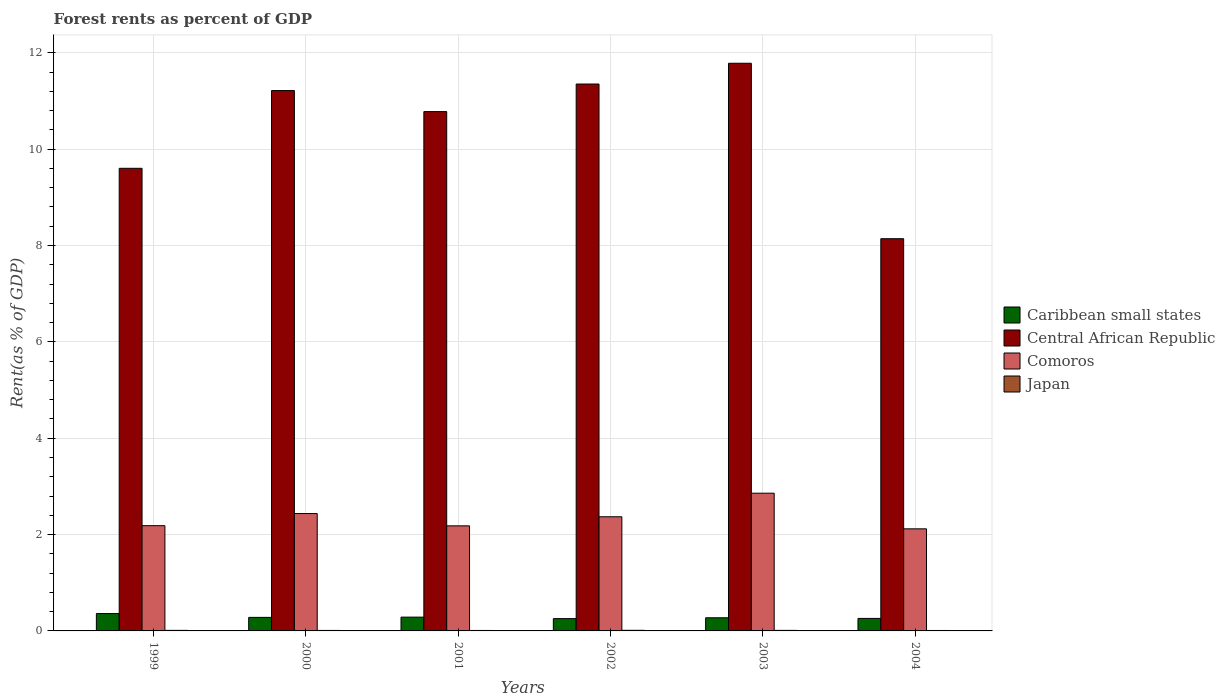How many groups of bars are there?
Your response must be concise. 6. Are the number of bars on each tick of the X-axis equal?
Give a very brief answer. Yes. What is the forest rent in Caribbean small states in 2001?
Your response must be concise. 0.29. Across all years, what is the maximum forest rent in Central African Republic?
Make the answer very short. 11.78. Across all years, what is the minimum forest rent in Comoros?
Your answer should be compact. 2.12. What is the total forest rent in Japan in the graph?
Provide a succinct answer. 0.06. What is the difference between the forest rent in Caribbean small states in 1999 and that in 2001?
Provide a short and direct response. 0.07. What is the difference between the forest rent in Caribbean small states in 2000 and the forest rent in Central African Republic in 1999?
Your response must be concise. -9.32. What is the average forest rent in Comoros per year?
Offer a very short reply. 2.36. In the year 2001, what is the difference between the forest rent in Comoros and forest rent in Japan?
Make the answer very short. 2.17. What is the ratio of the forest rent in Comoros in 1999 to that in 2000?
Keep it short and to the point. 0.9. Is the difference between the forest rent in Comoros in 2001 and 2003 greater than the difference between the forest rent in Japan in 2001 and 2003?
Give a very brief answer. No. What is the difference between the highest and the second highest forest rent in Japan?
Keep it short and to the point. 0. What is the difference between the highest and the lowest forest rent in Comoros?
Make the answer very short. 0.74. In how many years, is the forest rent in Japan greater than the average forest rent in Japan taken over all years?
Provide a succinct answer. 3. Is it the case that in every year, the sum of the forest rent in Central African Republic and forest rent in Japan is greater than the sum of forest rent in Comoros and forest rent in Caribbean small states?
Your answer should be very brief. Yes. What does the 1st bar from the left in 2000 represents?
Give a very brief answer. Caribbean small states. What does the 3rd bar from the right in 2000 represents?
Keep it short and to the point. Central African Republic. How many bars are there?
Your response must be concise. 24. Are all the bars in the graph horizontal?
Ensure brevity in your answer.  No. How many years are there in the graph?
Give a very brief answer. 6. What is the difference between two consecutive major ticks on the Y-axis?
Your answer should be compact. 2. Are the values on the major ticks of Y-axis written in scientific E-notation?
Make the answer very short. No. Does the graph contain any zero values?
Keep it short and to the point. No. How many legend labels are there?
Provide a short and direct response. 4. How are the legend labels stacked?
Your answer should be compact. Vertical. What is the title of the graph?
Offer a very short reply. Forest rents as percent of GDP. What is the label or title of the Y-axis?
Provide a succinct answer. Rent(as % of GDP). What is the Rent(as % of GDP) in Caribbean small states in 1999?
Give a very brief answer. 0.36. What is the Rent(as % of GDP) in Central African Republic in 1999?
Your answer should be very brief. 9.6. What is the Rent(as % of GDP) of Comoros in 1999?
Make the answer very short. 2.18. What is the Rent(as % of GDP) of Japan in 1999?
Your answer should be very brief. 0.01. What is the Rent(as % of GDP) in Caribbean small states in 2000?
Make the answer very short. 0.28. What is the Rent(as % of GDP) of Central African Republic in 2000?
Provide a short and direct response. 11.22. What is the Rent(as % of GDP) of Comoros in 2000?
Offer a very short reply. 2.44. What is the Rent(as % of GDP) in Japan in 2000?
Make the answer very short. 0.01. What is the Rent(as % of GDP) in Caribbean small states in 2001?
Give a very brief answer. 0.29. What is the Rent(as % of GDP) of Central African Republic in 2001?
Your response must be concise. 10.78. What is the Rent(as % of GDP) in Comoros in 2001?
Make the answer very short. 2.18. What is the Rent(as % of GDP) of Japan in 2001?
Keep it short and to the point. 0.01. What is the Rent(as % of GDP) in Caribbean small states in 2002?
Your answer should be compact. 0.26. What is the Rent(as % of GDP) of Central African Republic in 2002?
Provide a succinct answer. 11.35. What is the Rent(as % of GDP) in Comoros in 2002?
Keep it short and to the point. 2.37. What is the Rent(as % of GDP) in Japan in 2002?
Your response must be concise. 0.01. What is the Rent(as % of GDP) of Caribbean small states in 2003?
Your answer should be very brief. 0.27. What is the Rent(as % of GDP) of Central African Republic in 2003?
Make the answer very short. 11.78. What is the Rent(as % of GDP) in Comoros in 2003?
Your answer should be very brief. 2.86. What is the Rent(as % of GDP) in Japan in 2003?
Your response must be concise. 0.01. What is the Rent(as % of GDP) of Caribbean small states in 2004?
Make the answer very short. 0.26. What is the Rent(as % of GDP) in Central African Republic in 2004?
Your answer should be very brief. 8.14. What is the Rent(as % of GDP) of Comoros in 2004?
Your answer should be compact. 2.12. What is the Rent(as % of GDP) in Japan in 2004?
Your answer should be compact. 0.01. Across all years, what is the maximum Rent(as % of GDP) in Caribbean small states?
Provide a succinct answer. 0.36. Across all years, what is the maximum Rent(as % of GDP) in Central African Republic?
Provide a succinct answer. 11.78. Across all years, what is the maximum Rent(as % of GDP) in Comoros?
Your response must be concise. 2.86. Across all years, what is the maximum Rent(as % of GDP) of Japan?
Offer a terse response. 0.01. Across all years, what is the minimum Rent(as % of GDP) of Caribbean small states?
Keep it short and to the point. 0.26. Across all years, what is the minimum Rent(as % of GDP) of Central African Republic?
Provide a short and direct response. 8.14. Across all years, what is the minimum Rent(as % of GDP) of Comoros?
Offer a terse response. 2.12. Across all years, what is the minimum Rent(as % of GDP) in Japan?
Provide a succinct answer. 0.01. What is the total Rent(as % of GDP) in Caribbean small states in the graph?
Keep it short and to the point. 1.72. What is the total Rent(as % of GDP) of Central African Republic in the graph?
Your answer should be compact. 62.88. What is the total Rent(as % of GDP) of Comoros in the graph?
Ensure brevity in your answer.  14.15. What is the total Rent(as % of GDP) of Japan in the graph?
Provide a succinct answer. 0.06. What is the difference between the Rent(as % of GDP) of Caribbean small states in 1999 and that in 2000?
Your answer should be very brief. 0.08. What is the difference between the Rent(as % of GDP) in Central African Republic in 1999 and that in 2000?
Your response must be concise. -1.61. What is the difference between the Rent(as % of GDP) of Comoros in 1999 and that in 2000?
Ensure brevity in your answer.  -0.25. What is the difference between the Rent(as % of GDP) in Japan in 1999 and that in 2000?
Your response must be concise. 0. What is the difference between the Rent(as % of GDP) of Caribbean small states in 1999 and that in 2001?
Make the answer very short. 0.07. What is the difference between the Rent(as % of GDP) in Central African Republic in 1999 and that in 2001?
Offer a very short reply. -1.18. What is the difference between the Rent(as % of GDP) of Comoros in 1999 and that in 2001?
Offer a terse response. 0. What is the difference between the Rent(as % of GDP) of Japan in 1999 and that in 2001?
Provide a short and direct response. 0. What is the difference between the Rent(as % of GDP) in Caribbean small states in 1999 and that in 2002?
Offer a very short reply. 0.11. What is the difference between the Rent(as % of GDP) of Central African Republic in 1999 and that in 2002?
Keep it short and to the point. -1.75. What is the difference between the Rent(as % of GDP) in Comoros in 1999 and that in 2002?
Offer a terse response. -0.18. What is the difference between the Rent(as % of GDP) of Japan in 1999 and that in 2002?
Your response must be concise. -0. What is the difference between the Rent(as % of GDP) of Caribbean small states in 1999 and that in 2003?
Provide a short and direct response. 0.09. What is the difference between the Rent(as % of GDP) of Central African Republic in 1999 and that in 2003?
Provide a short and direct response. -2.18. What is the difference between the Rent(as % of GDP) of Comoros in 1999 and that in 2003?
Provide a succinct answer. -0.67. What is the difference between the Rent(as % of GDP) of Japan in 1999 and that in 2003?
Ensure brevity in your answer.  0. What is the difference between the Rent(as % of GDP) of Caribbean small states in 1999 and that in 2004?
Offer a very short reply. 0.1. What is the difference between the Rent(as % of GDP) of Central African Republic in 1999 and that in 2004?
Offer a terse response. 1.46. What is the difference between the Rent(as % of GDP) of Comoros in 1999 and that in 2004?
Your response must be concise. 0.07. What is the difference between the Rent(as % of GDP) of Japan in 1999 and that in 2004?
Ensure brevity in your answer.  0. What is the difference between the Rent(as % of GDP) of Caribbean small states in 2000 and that in 2001?
Provide a short and direct response. -0. What is the difference between the Rent(as % of GDP) of Central African Republic in 2000 and that in 2001?
Offer a very short reply. 0.44. What is the difference between the Rent(as % of GDP) of Comoros in 2000 and that in 2001?
Your answer should be very brief. 0.26. What is the difference between the Rent(as % of GDP) in Japan in 2000 and that in 2001?
Provide a short and direct response. 0. What is the difference between the Rent(as % of GDP) of Caribbean small states in 2000 and that in 2002?
Offer a terse response. 0.03. What is the difference between the Rent(as % of GDP) in Central African Republic in 2000 and that in 2002?
Offer a very short reply. -0.14. What is the difference between the Rent(as % of GDP) of Comoros in 2000 and that in 2002?
Offer a terse response. 0.07. What is the difference between the Rent(as % of GDP) of Japan in 2000 and that in 2002?
Give a very brief answer. -0. What is the difference between the Rent(as % of GDP) in Caribbean small states in 2000 and that in 2003?
Give a very brief answer. 0.01. What is the difference between the Rent(as % of GDP) of Central African Republic in 2000 and that in 2003?
Provide a succinct answer. -0.57. What is the difference between the Rent(as % of GDP) in Comoros in 2000 and that in 2003?
Your answer should be very brief. -0.42. What is the difference between the Rent(as % of GDP) of Japan in 2000 and that in 2003?
Offer a very short reply. -0. What is the difference between the Rent(as % of GDP) in Caribbean small states in 2000 and that in 2004?
Offer a terse response. 0.02. What is the difference between the Rent(as % of GDP) in Central African Republic in 2000 and that in 2004?
Your answer should be very brief. 3.08. What is the difference between the Rent(as % of GDP) in Comoros in 2000 and that in 2004?
Make the answer very short. 0.32. What is the difference between the Rent(as % of GDP) in Caribbean small states in 2001 and that in 2002?
Offer a very short reply. 0.03. What is the difference between the Rent(as % of GDP) in Central African Republic in 2001 and that in 2002?
Your response must be concise. -0.57. What is the difference between the Rent(as % of GDP) of Comoros in 2001 and that in 2002?
Your response must be concise. -0.19. What is the difference between the Rent(as % of GDP) in Japan in 2001 and that in 2002?
Offer a very short reply. -0. What is the difference between the Rent(as % of GDP) of Caribbean small states in 2001 and that in 2003?
Ensure brevity in your answer.  0.01. What is the difference between the Rent(as % of GDP) of Central African Republic in 2001 and that in 2003?
Offer a terse response. -1. What is the difference between the Rent(as % of GDP) in Comoros in 2001 and that in 2003?
Offer a terse response. -0.68. What is the difference between the Rent(as % of GDP) of Japan in 2001 and that in 2003?
Keep it short and to the point. -0. What is the difference between the Rent(as % of GDP) of Caribbean small states in 2001 and that in 2004?
Ensure brevity in your answer.  0.03. What is the difference between the Rent(as % of GDP) in Central African Republic in 2001 and that in 2004?
Provide a short and direct response. 2.64. What is the difference between the Rent(as % of GDP) in Comoros in 2001 and that in 2004?
Ensure brevity in your answer.  0.06. What is the difference between the Rent(as % of GDP) in Japan in 2001 and that in 2004?
Offer a terse response. 0. What is the difference between the Rent(as % of GDP) of Caribbean small states in 2002 and that in 2003?
Your answer should be compact. -0.02. What is the difference between the Rent(as % of GDP) of Central African Republic in 2002 and that in 2003?
Provide a short and direct response. -0.43. What is the difference between the Rent(as % of GDP) of Comoros in 2002 and that in 2003?
Your response must be concise. -0.49. What is the difference between the Rent(as % of GDP) of Japan in 2002 and that in 2003?
Make the answer very short. 0. What is the difference between the Rent(as % of GDP) of Caribbean small states in 2002 and that in 2004?
Keep it short and to the point. -0. What is the difference between the Rent(as % of GDP) of Central African Republic in 2002 and that in 2004?
Your response must be concise. 3.21. What is the difference between the Rent(as % of GDP) in Comoros in 2002 and that in 2004?
Offer a terse response. 0.25. What is the difference between the Rent(as % of GDP) in Japan in 2002 and that in 2004?
Your response must be concise. 0. What is the difference between the Rent(as % of GDP) in Caribbean small states in 2003 and that in 2004?
Provide a succinct answer. 0.01. What is the difference between the Rent(as % of GDP) of Central African Republic in 2003 and that in 2004?
Offer a very short reply. 3.64. What is the difference between the Rent(as % of GDP) of Comoros in 2003 and that in 2004?
Keep it short and to the point. 0.74. What is the difference between the Rent(as % of GDP) in Japan in 2003 and that in 2004?
Give a very brief answer. 0. What is the difference between the Rent(as % of GDP) in Caribbean small states in 1999 and the Rent(as % of GDP) in Central African Republic in 2000?
Your answer should be very brief. -10.86. What is the difference between the Rent(as % of GDP) in Caribbean small states in 1999 and the Rent(as % of GDP) in Comoros in 2000?
Offer a very short reply. -2.08. What is the difference between the Rent(as % of GDP) of Caribbean small states in 1999 and the Rent(as % of GDP) of Japan in 2000?
Offer a terse response. 0.35. What is the difference between the Rent(as % of GDP) in Central African Republic in 1999 and the Rent(as % of GDP) in Comoros in 2000?
Offer a very short reply. 7.17. What is the difference between the Rent(as % of GDP) of Central African Republic in 1999 and the Rent(as % of GDP) of Japan in 2000?
Offer a very short reply. 9.59. What is the difference between the Rent(as % of GDP) in Comoros in 1999 and the Rent(as % of GDP) in Japan in 2000?
Offer a very short reply. 2.17. What is the difference between the Rent(as % of GDP) of Caribbean small states in 1999 and the Rent(as % of GDP) of Central African Republic in 2001?
Offer a terse response. -10.42. What is the difference between the Rent(as % of GDP) in Caribbean small states in 1999 and the Rent(as % of GDP) in Comoros in 2001?
Offer a terse response. -1.82. What is the difference between the Rent(as % of GDP) of Caribbean small states in 1999 and the Rent(as % of GDP) of Japan in 2001?
Ensure brevity in your answer.  0.35. What is the difference between the Rent(as % of GDP) in Central African Republic in 1999 and the Rent(as % of GDP) in Comoros in 2001?
Offer a terse response. 7.42. What is the difference between the Rent(as % of GDP) in Central African Republic in 1999 and the Rent(as % of GDP) in Japan in 2001?
Your answer should be compact. 9.59. What is the difference between the Rent(as % of GDP) of Comoros in 1999 and the Rent(as % of GDP) of Japan in 2001?
Keep it short and to the point. 2.17. What is the difference between the Rent(as % of GDP) of Caribbean small states in 1999 and the Rent(as % of GDP) of Central African Republic in 2002?
Give a very brief answer. -10.99. What is the difference between the Rent(as % of GDP) in Caribbean small states in 1999 and the Rent(as % of GDP) in Comoros in 2002?
Offer a very short reply. -2.01. What is the difference between the Rent(as % of GDP) in Caribbean small states in 1999 and the Rent(as % of GDP) in Japan in 2002?
Keep it short and to the point. 0.35. What is the difference between the Rent(as % of GDP) of Central African Republic in 1999 and the Rent(as % of GDP) of Comoros in 2002?
Provide a short and direct response. 7.23. What is the difference between the Rent(as % of GDP) in Central African Republic in 1999 and the Rent(as % of GDP) in Japan in 2002?
Your response must be concise. 9.59. What is the difference between the Rent(as % of GDP) in Comoros in 1999 and the Rent(as % of GDP) in Japan in 2002?
Make the answer very short. 2.17. What is the difference between the Rent(as % of GDP) of Caribbean small states in 1999 and the Rent(as % of GDP) of Central African Republic in 2003?
Provide a short and direct response. -11.42. What is the difference between the Rent(as % of GDP) of Caribbean small states in 1999 and the Rent(as % of GDP) of Comoros in 2003?
Offer a terse response. -2.5. What is the difference between the Rent(as % of GDP) of Caribbean small states in 1999 and the Rent(as % of GDP) of Japan in 2003?
Offer a terse response. 0.35. What is the difference between the Rent(as % of GDP) of Central African Republic in 1999 and the Rent(as % of GDP) of Comoros in 2003?
Make the answer very short. 6.74. What is the difference between the Rent(as % of GDP) in Central African Republic in 1999 and the Rent(as % of GDP) in Japan in 2003?
Give a very brief answer. 9.59. What is the difference between the Rent(as % of GDP) in Comoros in 1999 and the Rent(as % of GDP) in Japan in 2003?
Provide a short and direct response. 2.17. What is the difference between the Rent(as % of GDP) of Caribbean small states in 1999 and the Rent(as % of GDP) of Central African Republic in 2004?
Ensure brevity in your answer.  -7.78. What is the difference between the Rent(as % of GDP) of Caribbean small states in 1999 and the Rent(as % of GDP) of Comoros in 2004?
Offer a terse response. -1.76. What is the difference between the Rent(as % of GDP) in Caribbean small states in 1999 and the Rent(as % of GDP) in Japan in 2004?
Your answer should be compact. 0.35. What is the difference between the Rent(as % of GDP) in Central African Republic in 1999 and the Rent(as % of GDP) in Comoros in 2004?
Your response must be concise. 7.48. What is the difference between the Rent(as % of GDP) in Central African Republic in 1999 and the Rent(as % of GDP) in Japan in 2004?
Provide a short and direct response. 9.59. What is the difference between the Rent(as % of GDP) in Comoros in 1999 and the Rent(as % of GDP) in Japan in 2004?
Provide a succinct answer. 2.18. What is the difference between the Rent(as % of GDP) of Caribbean small states in 2000 and the Rent(as % of GDP) of Central African Republic in 2001?
Provide a short and direct response. -10.5. What is the difference between the Rent(as % of GDP) in Caribbean small states in 2000 and the Rent(as % of GDP) in Comoros in 2001?
Ensure brevity in your answer.  -1.9. What is the difference between the Rent(as % of GDP) of Caribbean small states in 2000 and the Rent(as % of GDP) of Japan in 2001?
Your answer should be compact. 0.27. What is the difference between the Rent(as % of GDP) of Central African Republic in 2000 and the Rent(as % of GDP) of Comoros in 2001?
Offer a very short reply. 9.04. What is the difference between the Rent(as % of GDP) in Central African Republic in 2000 and the Rent(as % of GDP) in Japan in 2001?
Provide a short and direct response. 11.21. What is the difference between the Rent(as % of GDP) of Comoros in 2000 and the Rent(as % of GDP) of Japan in 2001?
Keep it short and to the point. 2.43. What is the difference between the Rent(as % of GDP) of Caribbean small states in 2000 and the Rent(as % of GDP) of Central African Republic in 2002?
Your answer should be very brief. -11.07. What is the difference between the Rent(as % of GDP) in Caribbean small states in 2000 and the Rent(as % of GDP) in Comoros in 2002?
Keep it short and to the point. -2.09. What is the difference between the Rent(as % of GDP) in Caribbean small states in 2000 and the Rent(as % of GDP) in Japan in 2002?
Provide a short and direct response. 0.27. What is the difference between the Rent(as % of GDP) in Central African Republic in 2000 and the Rent(as % of GDP) in Comoros in 2002?
Your answer should be very brief. 8.85. What is the difference between the Rent(as % of GDP) in Central African Republic in 2000 and the Rent(as % of GDP) in Japan in 2002?
Ensure brevity in your answer.  11.2. What is the difference between the Rent(as % of GDP) in Comoros in 2000 and the Rent(as % of GDP) in Japan in 2002?
Keep it short and to the point. 2.42. What is the difference between the Rent(as % of GDP) of Caribbean small states in 2000 and the Rent(as % of GDP) of Central African Republic in 2003?
Your answer should be very brief. -11.5. What is the difference between the Rent(as % of GDP) of Caribbean small states in 2000 and the Rent(as % of GDP) of Comoros in 2003?
Provide a succinct answer. -2.58. What is the difference between the Rent(as % of GDP) in Caribbean small states in 2000 and the Rent(as % of GDP) in Japan in 2003?
Offer a terse response. 0.27. What is the difference between the Rent(as % of GDP) in Central African Republic in 2000 and the Rent(as % of GDP) in Comoros in 2003?
Make the answer very short. 8.36. What is the difference between the Rent(as % of GDP) of Central African Republic in 2000 and the Rent(as % of GDP) of Japan in 2003?
Give a very brief answer. 11.21. What is the difference between the Rent(as % of GDP) of Comoros in 2000 and the Rent(as % of GDP) of Japan in 2003?
Ensure brevity in your answer.  2.43. What is the difference between the Rent(as % of GDP) of Caribbean small states in 2000 and the Rent(as % of GDP) of Central African Republic in 2004?
Your answer should be very brief. -7.86. What is the difference between the Rent(as % of GDP) of Caribbean small states in 2000 and the Rent(as % of GDP) of Comoros in 2004?
Make the answer very short. -1.84. What is the difference between the Rent(as % of GDP) of Caribbean small states in 2000 and the Rent(as % of GDP) of Japan in 2004?
Give a very brief answer. 0.27. What is the difference between the Rent(as % of GDP) in Central African Republic in 2000 and the Rent(as % of GDP) in Comoros in 2004?
Give a very brief answer. 9.1. What is the difference between the Rent(as % of GDP) of Central African Republic in 2000 and the Rent(as % of GDP) of Japan in 2004?
Offer a terse response. 11.21. What is the difference between the Rent(as % of GDP) in Comoros in 2000 and the Rent(as % of GDP) in Japan in 2004?
Your response must be concise. 2.43. What is the difference between the Rent(as % of GDP) of Caribbean small states in 2001 and the Rent(as % of GDP) of Central African Republic in 2002?
Provide a short and direct response. -11.07. What is the difference between the Rent(as % of GDP) in Caribbean small states in 2001 and the Rent(as % of GDP) in Comoros in 2002?
Keep it short and to the point. -2.08. What is the difference between the Rent(as % of GDP) in Caribbean small states in 2001 and the Rent(as % of GDP) in Japan in 2002?
Keep it short and to the point. 0.27. What is the difference between the Rent(as % of GDP) of Central African Republic in 2001 and the Rent(as % of GDP) of Comoros in 2002?
Provide a succinct answer. 8.41. What is the difference between the Rent(as % of GDP) of Central African Republic in 2001 and the Rent(as % of GDP) of Japan in 2002?
Provide a succinct answer. 10.77. What is the difference between the Rent(as % of GDP) in Comoros in 2001 and the Rent(as % of GDP) in Japan in 2002?
Offer a terse response. 2.17. What is the difference between the Rent(as % of GDP) of Caribbean small states in 2001 and the Rent(as % of GDP) of Central African Republic in 2003?
Your answer should be very brief. -11.5. What is the difference between the Rent(as % of GDP) in Caribbean small states in 2001 and the Rent(as % of GDP) in Comoros in 2003?
Provide a succinct answer. -2.57. What is the difference between the Rent(as % of GDP) in Caribbean small states in 2001 and the Rent(as % of GDP) in Japan in 2003?
Give a very brief answer. 0.28. What is the difference between the Rent(as % of GDP) in Central African Republic in 2001 and the Rent(as % of GDP) in Comoros in 2003?
Keep it short and to the point. 7.92. What is the difference between the Rent(as % of GDP) of Central African Republic in 2001 and the Rent(as % of GDP) of Japan in 2003?
Your response must be concise. 10.77. What is the difference between the Rent(as % of GDP) of Comoros in 2001 and the Rent(as % of GDP) of Japan in 2003?
Give a very brief answer. 2.17. What is the difference between the Rent(as % of GDP) in Caribbean small states in 2001 and the Rent(as % of GDP) in Central African Republic in 2004?
Ensure brevity in your answer.  -7.86. What is the difference between the Rent(as % of GDP) of Caribbean small states in 2001 and the Rent(as % of GDP) of Comoros in 2004?
Keep it short and to the point. -1.83. What is the difference between the Rent(as % of GDP) in Caribbean small states in 2001 and the Rent(as % of GDP) in Japan in 2004?
Your response must be concise. 0.28. What is the difference between the Rent(as % of GDP) in Central African Republic in 2001 and the Rent(as % of GDP) in Comoros in 2004?
Offer a very short reply. 8.66. What is the difference between the Rent(as % of GDP) of Central African Republic in 2001 and the Rent(as % of GDP) of Japan in 2004?
Ensure brevity in your answer.  10.77. What is the difference between the Rent(as % of GDP) in Comoros in 2001 and the Rent(as % of GDP) in Japan in 2004?
Provide a succinct answer. 2.17. What is the difference between the Rent(as % of GDP) in Caribbean small states in 2002 and the Rent(as % of GDP) in Central African Republic in 2003?
Give a very brief answer. -11.53. What is the difference between the Rent(as % of GDP) of Caribbean small states in 2002 and the Rent(as % of GDP) of Comoros in 2003?
Your answer should be very brief. -2.6. What is the difference between the Rent(as % of GDP) in Caribbean small states in 2002 and the Rent(as % of GDP) in Japan in 2003?
Your answer should be very brief. 0.24. What is the difference between the Rent(as % of GDP) in Central African Republic in 2002 and the Rent(as % of GDP) in Comoros in 2003?
Offer a terse response. 8.49. What is the difference between the Rent(as % of GDP) in Central African Republic in 2002 and the Rent(as % of GDP) in Japan in 2003?
Ensure brevity in your answer.  11.34. What is the difference between the Rent(as % of GDP) of Comoros in 2002 and the Rent(as % of GDP) of Japan in 2003?
Your response must be concise. 2.36. What is the difference between the Rent(as % of GDP) in Caribbean small states in 2002 and the Rent(as % of GDP) in Central African Republic in 2004?
Offer a terse response. -7.89. What is the difference between the Rent(as % of GDP) of Caribbean small states in 2002 and the Rent(as % of GDP) of Comoros in 2004?
Offer a terse response. -1.86. What is the difference between the Rent(as % of GDP) of Caribbean small states in 2002 and the Rent(as % of GDP) of Japan in 2004?
Offer a very short reply. 0.25. What is the difference between the Rent(as % of GDP) in Central African Republic in 2002 and the Rent(as % of GDP) in Comoros in 2004?
Ensure brevity in your answer.  9.23. What is the difference between the Rent(as % of GDP) in Central African Republic in 2002 and the Rent(as % of GDP) in Japan in 2004?
Provide a short and direct response. 11.34. What is the difference between the Rent(as % of GDP) in Comoros in 2002 and the Rent(as % of GDP) in Japan in 2004?
Your response must be concise. 2.36. What is the difference between the Rent(as % of GDP) in Caribbean small states in 2003 and the Rent(as % of GDP) in Central African Republic in 2004?
Make the answer very short. -7.87. What is the difference between the Rent(as % of GDP) in Caribbean small states in 2003 and the Rent(as % of GDP) in Comoros in 2004?
Provide a succinct answer. -1.85. What is the difference between the Rent(as % of GDP) in Caribbean small states in 2003 and the Rent(as % of GDP) in Japan in 2004?
Ensure brevity in your answer.  0.26. What is the difference between the Rent(as % of GDP) of Central African Republic in 2003 and the Rent(as % of GDP) of Comoros in 2004?
Offer a terse response. 9.66. What is the difference between the Rent(as % of GDP) of Central African Republic in 2003 and the Rent(as % of GDP) of Japan in 2004?
Offer a terse response. 11.77. What is the difference between the Rent(as % of GDP) in Comoros in 2003 and the Rent(as % of GDP) in Japan in 2004?
Offer a very short reply. 2.85. What is the average Rent(as % of GDP) of Caribbean small states per year?
Keep it short and to the point. 0.29. What is the average Rent(as % of GDP) in Central African Republic per year?
Give a very brief answer. 10.48. What is the average Rent(as % of GDP) of Comoros per year?
Give a very brief answer. 2.36. What is the average Rent(as % of GDP) in Japan per year?
Provide a succinct answer. 0.01. In the year 1999, what is the difference between the Rent(as % of GDP) in Caribbean small states and Rent(as % of GDP) in Central African Republic?
Keep it short and to the point. -9.24. In the year 1999, what is the difference between the Rent(as % of GDP) in Caribbean small states and Rent(as % of GDP) in Comoros?
Keep it short and to the point. -1.82. In the year 1999, what is the difference between the Rent(as % of GDP) in Caribbean small states and Rent(as % of GDP) in Japan?
Your answer should be very brief. 0.35. In the year 1999, what is the difference between the Rent(as % of GDP) of Central African Republic and Rent(as % of GDP) of Comoros?
Make the answer very short. 7.42. In the year 1999, what is the difference between the Rent(as % of GDP) in Central African Republic and Rent(as % of GDP) in Japan?
Keep it short and to the point. 9.59. In the year 1999, what is the difference between the Rent(as % of GDP) of Comoros and Rent(as % of GDP) of Japan?
Your answer should be very brief. 2.17. In the year 2000, what is the difference between the Rent(as % of GDP) of Caribbean small states and Rent(as % of GDP) of Central African Republic?
Provide a succinct answer. -10.94. In the year 2000, what is the difference between the Rent(as % of GDP) in Caribbean small states and Rent(as % of GDP) in Comoros?
Ensure brevity in your answer.  -2.15. In the year 2000, what is the difference between the Rent(as % of GDP) in Caribbean small states and Rent(as % of GDP) in Japan?
Your answer should be very brief. 0.27. In the year 2000, what is the difference between the Rent(as % of GDP) in Central African Republic and Rent(as % of GDP) in Comoros?
Keep it short and to the point. 8.78. In the year 2000, what is the difference between the Rent(as % of GDP) of Central African Republic and Rent(as % of GDP) of Japan?
Your answer should be compact. 11.21. In the year 2000, what is the difference between the Rent(as % of GDP) of Comoros and Rent(as % of GDP) of Japan?
Provide a short and direct response. 2.43. In the year 2001, what is the difference between the Rent(as % of GDP) of Caribbean small states and Rent(as % of GDP) of Central African Republic?
Give a very brief answer. -10.49. In the year 2001, what is the difference between the Rent(as % of GDP) in Caribbean small states and Rent(as % of GDP) in Comoros?
Offer a very short reply. -1.9. In the year 2001, what is the difference between the Rent(as % of GDP) of Caribbean small states and Rent(as % of GDP) of Japan?
Ensure brevity in your answer.  0.28. In the year 2001, what is the difference between the Rent(as % of GDP) of Central African Republic and Rent(as % of GDP) of Comoros?
Your answer should be compact. 8.6. In the year 2001, what is the difference between the Rent(as % of GDP) in Central African Republic and Rent(as % of GDP) in Japan?
Ensure brevity in your answer.  10.77. In the year 2001, what is the difference between the Rent(as % of GDP) of Comoros and Rent(as % of GDP) of Japan?
Provide a succinct answer. 2.17. In the year 2002, what is the difference between the Rent(as % of GDP) of Caribbean small states and Rent(as % of GDP) of Central African Republic?
Provide a short and direct response. -11.1. In the year 2002, what is the difference between the Rent(as % of GDP) in Caribbean small states and Rent(as % of GDP) in Comoros?
Offer a terse response. -2.11. In the year 2002, what is the difference between the Rent(as % of GDP) of Caribbean small states and Rent(as % of GDP) of Japan?
Your answer should be compact. 0.24. In the year 2002, what is the difference between the Rent(as % of GDP) in Central African Republic and Rent(as % of GDP) in Comoros?
Keep it short and to the point. 8.98. In the year 2002, what is the difference between the Rent(as % of GDP) of Central African Republic and Rent(as % of GDP) of Japan?
Provide a short and direct response. 11.34. In the year 2002, what is the difference between the Rent(as % of GDP) in Comoros and Rent(as % of GDP) in Japan?
Your response must be concise. 2.36. In the year 2003, what is the difference between the Rent(as % of GDP) in Caribbean small states and Rent(as % of GDP) in Central African Republic?
Your answer should be compact. -11.51. In the year 2003, what is the difference between the Rent(as % of GDP) in Caribbean small states and Rent(as % of GDP) in Comoros?
Provide a short and direct response. -2.59. In the year 2003, what is the difference between the Rent(as % of GDP) of Caribbean small states and Rent(as % of GDP) of Japan?
Give a very brief answer. 0.26. In the year 2003, what is the difference between the Rent(as % of GDP) of Central African Republic and Rent(as % of GDP) of Comoros?
Your answer should be compact. 8.92. In the year 2003, what is the difference between the Rent(as % of GDP) in Central African Republic and Rent(as % of GDP) in Japan?
Offer a very short reply. 11.77. In the year 2003, what is the difference between the Rent(as % of GDP) of Comoros and Rent(as % of GDP) of Japan?
Ensure brevity in your answer.  2.85. In the year 2004, what is the difference between the Rent(as % of GDP) in Caribbean small states and Rent(as % of GDP) in Central African Republic?
Give a very brief answer. -7.88. In the year 2004, what is the difference between the Rent(as % of GDP) of Caribbean small states and Rent(as % of GDP) of Comoros?
Provide a short and direct response. -1.86. In the year 2004, what is the difference between the Rent(as % of GDP) of Caribbean small states and Rent(as % of GDP) of Japan?
Keep it short and to the point. 0.25. In the year 2004, what is the difference between the Rent(as % of GDP) in Central African Republic and Rent(as % of GDP) in Comoros?
Offer a terse response. 6.02. In the year 2004, what is the difference between the Rent(as % of GDP) in Central African Republic and Rent(as % of GDP) in Japan?
Ensure brevity in your answer.  8.13. In the year 2004, what is the difference between the Rent(as % of GDP) of Comoros and Rent(as % of GDP) of Japan?
Your answer should be compact. 2.11. What is the ratio of the Rent(as % of GDP) of Caribbean small states in 1999 to that in 2000?
Offer a terse response. 1.28. What is the ratio of the Rent(as % of GDP) of Central African Republic in 1999 to that in 2000?
Your answer should be compact. 0.86. What is the ratio of the Rent(as % of GDP) in Comoros in 1999 to that in 2000?
Your answer should be compact. 0.9. What is the ratio of the Rent(as % of GDP) of Japan in 1999 to that in 2000?
Provide a succinct answer. 1.11. What is the ratio of the Rent(as % of GDP) of Caribbean small states in 1999 to that in 2001?
Make the answer very short. 1.26. What is the ratio of the Rent(as % of GDP) of Central African Republic in 1999 to that in 2001?
Your response must be concise. 0.89. What is the ratio of the Rent(as % of GDP) in Japan in 1999 to that in 2001?
Offer a terse response. 1.18. What is the ratio of the Rent(as % of GDP) of Caribbean small states in 1999 to that in 2002?
Offer a terse response. 1.41. What is the ratio of the Rent(as % of GDP) of Central African Republic in 1999 to that in 2002?
Make the answer very short. 0.85. What is the ratio of the Rent(as % of GDP) of Comoros in 1999 to that in 2002?
Your response must be concise. 0.92. What is the ratio of the Rent(as % of GDP) of Japan in 1999 to that in 2002?
Offer a very short reply. 0.93. What is the ratio of the Rent(as % of GDP) in Caribbean small states in 1999 to that in 2003?
Offer a very short reply. 1.32. What is the ratio of the Rent(as % of GDP) of Central African Republic in 1999 to that in 2003?
Provide a succinct answer. 0.81. What is the ratio of the Rent(as % of GDP) of Comoros in 1999 to that in 2003?
Your response must be concise. 0.76. What is the ratio of the Rent(as % of GDP) of Japan in 1999 to that in 2003?
Offer a terse response. 1.03. What is the ratio of the Rent(as % of GDP) in Caribbean small states in 1999 to that in 2004?
Provide a short and direct response. 1.39. What is the ratio of the Rent(as % of GDP) in Central African Republic in 1999 to that in 2004?
Make the answer very short. 1.18. What is the ratio of the Rent(as % of GDP) of Comoros in 1999 to that in 2004?
Your answer should be compact. 1.03. What is the ratio of the Rent(as % of GDP) of Japan in 1999 to that in 2004?
Your response must be concise. 1.23. What is the ratio of the Rent(as % of GDP) in Caribbean small states in 2000 to that in 2001?
Make the answer very short. 0.98. What is the ratio of the Rent(as % of GDP) in Central African Republic in 2000 to that in 2001?
Provide a succinct answer. 1.04. What is the ratio of the Rent(as % of GDP) of Comoros in 2000 to that in 2001?
Give a very brief answer. 1.12. What is the ratio of the Rent(as % of GDP) of Japan in 2000 to that in 2001?
Your answer should be compact. 1.06. What is the ratio of the Rent(as % of GDP) in Caribbean small states in 2000 to that in 2002?
Make the answer very short. 1.1. What is the ratio of the Rent(as % of GDP) of Comoros in 2000 to that in 2002?
Your answer should be very brief. 1.03. What is the ratio of the Rent(as % of GDP) in Japan in 2000 to that in 2002?
Provide a succinct answer. 0.83. What is the ratio of the Rent(as % of GDP) in Caribbean small states in 2000 to that in 2003?
Make the answer very short. 1.03. What is the ratio of the Rent(as % of GDP) of Central African Republic in 2000 to that in 2003?
Offer a terse response. 0.95. What is the ratio of the Rent(as % of GDP) of Comoros in 2000 to that in 2003?
Keep it short and to the point. 0.85. What is the ratio of the Rent(as % of GDP) of Japan in 2000 to that in 2003?
Provide a succinct answer. 0.93. What is the ratio of the Rent(as % of GDP) of Caribbean small states in 2000 to that in 2004?
Your answer should be very brief. 1.08. What is the ratio of the Rent(as % of GDP) in Central African Republic in 2000 to that in 2004?
Provide a succinct answer. 1.38. What is the ratio of the Rent(as % of GDP) of Comoros in 2000 to that in 2004?
Your response must be concise. 1.15. What is the ratio of the Rent(as % of GDP) in Japan in 2000 to that in 2004?
Your answer should be very brief. 1.11. What is the ratio of the Rent(as % of GDP) of Caribbean small states in 2001 to that in 2002?
Provide a short and direct response. 1.12. What is the ratio of the Rent(as % of GDP) in Central African Republic in 2001 to that in 2002?
Your answer should be very brief. 0.95. What is the ratio of the Rent(as % of GDP) in Comoros in 2001 to that in 2002?
Offer a very short reply. 0.92. What is the ratio of the Rent(as % of GDP) in Japan in 2001 to that in 2002?
Keep it short and to the point. 0.79. What is the ratio of the Rent(as % of GDP) in Caribbean small states in 2001 to that in 2003?
Make the answer very short. 1.05. What is the ratio of the Rent(as % of GDP) in Central African Republic in 2001 to that in 2003?
Ensure brevity in your answer.  0.91. What is the ratio of the Rent(as % of GDP) of Comoros in 2001 to that in 2003?
Keep it short and to the point. 0.76. What is the ratio of the Rent(as % of GDP) in Japan in 2001 to that in 2003?
Offer a terse response. 0.87. What is the ratio of the Rent(as % of GDP) in Caribbean small states in 2001 to that in 2004?
Make the answer very short. 1.1. What is the ratio of the Rent(as % of GDP) of Central African Republic in 2001 to that in 2004?
Offer a very short reply. 1.32. What is the ratio of the Rent(as % of GDP) of Comoros in 2001 to that in 2004?
Your answer should be very brief. 1.03. What is the ratio of the Rent(as % of GDP) in Japan in 2001 to that in 2004?
Give a very brief answer. 1.05. What is the ratio of the Rent(as % of GDP) of Caribbean small states in 2002 to that in 2003?
Give a very brief answer. 0.93. What is the ratio of the Rent(as % of GDP) of Central African Republic in 2002 to that in 2003?
Your response must be concise. 0.96. What is the ratio of the Rent(as % of GDP) in Comoros in 2002 to that in 2003?
Provide a short and direct response. 0.83. What is the ratio of the Rent(as % of GDP) in Japan in 2002 to that in 2003?
Keep it short and to the point. 1.11. What is the ratio of the Rent(as % of GDP) in Caribbean small states in 2002 to that in 2004?
Keep it short and to the point. 0.98. What is the ratio of the Rent(as % of GDP) of Central African Republic in 2002 to that in 2004?
Your response must be concise. 1.39. What is the ratio of the Rent(as % of GDP) of Comoros in 2002 to that in 2004?
Give a very brief answer. 1.12. What is the ratio of the Rent(as % of GDP) in Japan in 2002 to that in 2004?
Provide a short and direct response. 1.33. What is the ratio of the Rent(as % of GDP) of Caribbean small states in 2003 to that in 2004?
Your answer should be very brief. 1.05. What is the ratio of the Rent(as % of GDP) of Central African Republic in 2003 to that in 2004?
Offer a terse response. 1.45. What is the ratio of the Rent(as % of GDP) of Comoros in 2003 to that in 2004?
Your answer should be very brief. 1.35. What is the ratio of the Rent(as % of GDP) of Japan in 2003 to that in 2004?
Provide a succinct answer. 1.2. What is the difference between the highest and the second highest Rent(as % of GDP) in Caribbean small states?
Your answer should be very brief. 0.07. What is the difference between the highest and the second highest Rent(as % of GDP) in Central African Republic?
Your response must be concise. 0.43. What is the difference between the highest and the second highest Rent(as % of GDP) in Comoros?
Your answer should be compact. 0.42. What is the difference between the highest and the second highest Rent(as % of GDP) of Japan?
Offer a very short reply. 0. What is the difference between the highest and the lowest Rent(as % of GDP) in Caribbean small states?
Make the answer very short. 0.11. What is the difference between the highest and the lowest Rent(as % of GDP) of Central African Republic?
Make the answer very short. 3.64. What is the difference between the highest and the lowest Rent(as % of GDP) of Comoros?
Your answer should be very brief. 0.74. What is the difference between the highest and the lowest Rent(as % of GDP) in Japan?
Offer a terse response. 0. 